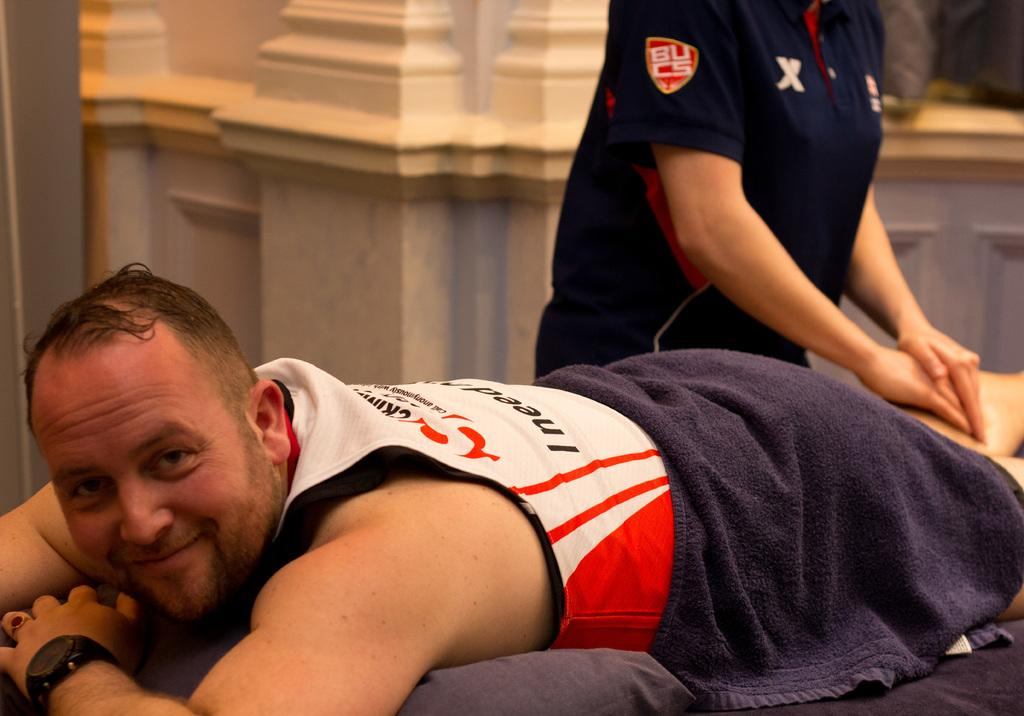<image>
Give a short and clear explanation of the subsequent image. Soccer player being massaged by a women wearing a shirt that says, B.U.C.S. 